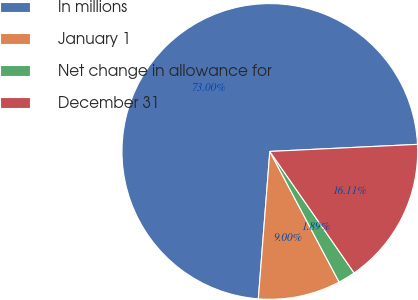Convert chart. <chart><loc_0><loc_0><loc_500><loc_500><pie_chart><fcel>In millions<fcel>January 1<fcel>Net change in allowance for<fcel>December 31<nl><fcel>73.0%<fcel>9.0%<fcel>1.89%<fcel>16.11%<nl></chart> 